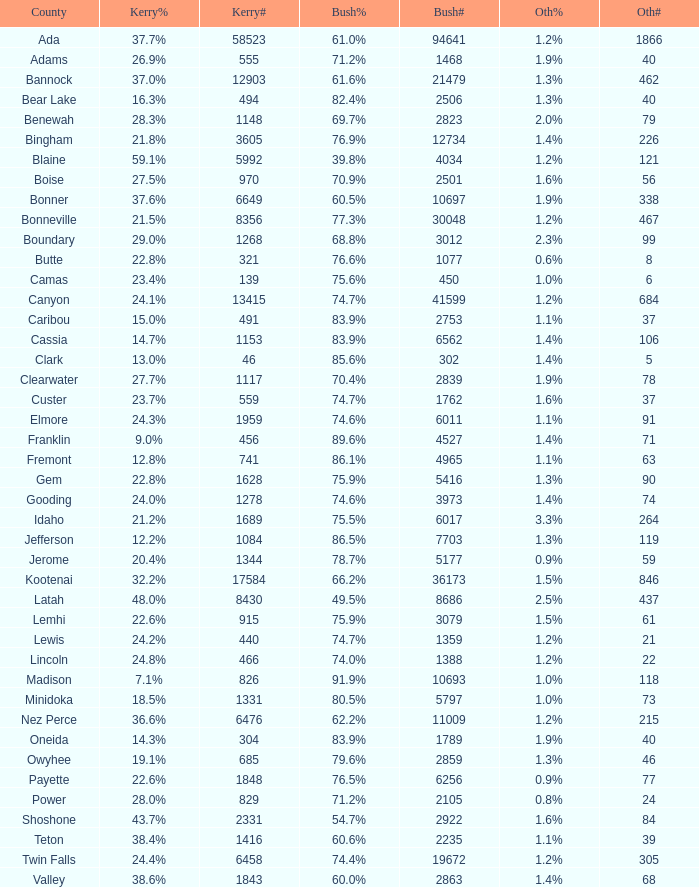What percentage of the votes were for others in the county where 462 people voted that way? 1.3%. 